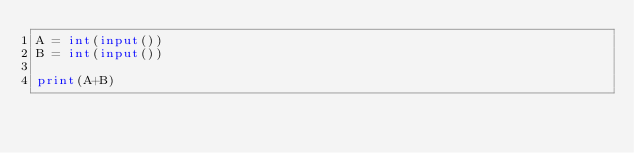Convert code to text. <code><loc_0><loc_0><loc_500><loc_500><_Python_>A = int(input())
B = int(input())

print(A+B)</code> 